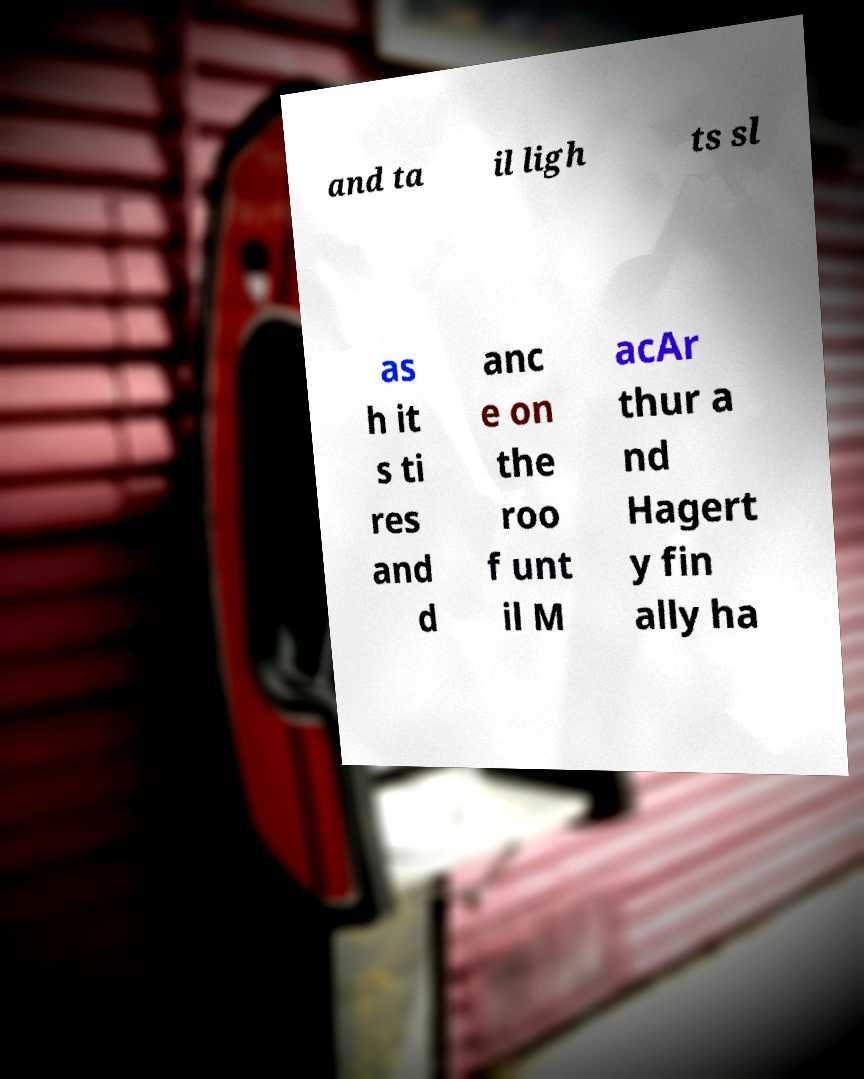There's text embedded in this image that I need extracted. Can you transcribe it verbatim? and ta il ligh ts sl as h it s ti res and d anc e on the roo f unt il M acAr thur a nd Hagert y fin ally ha 